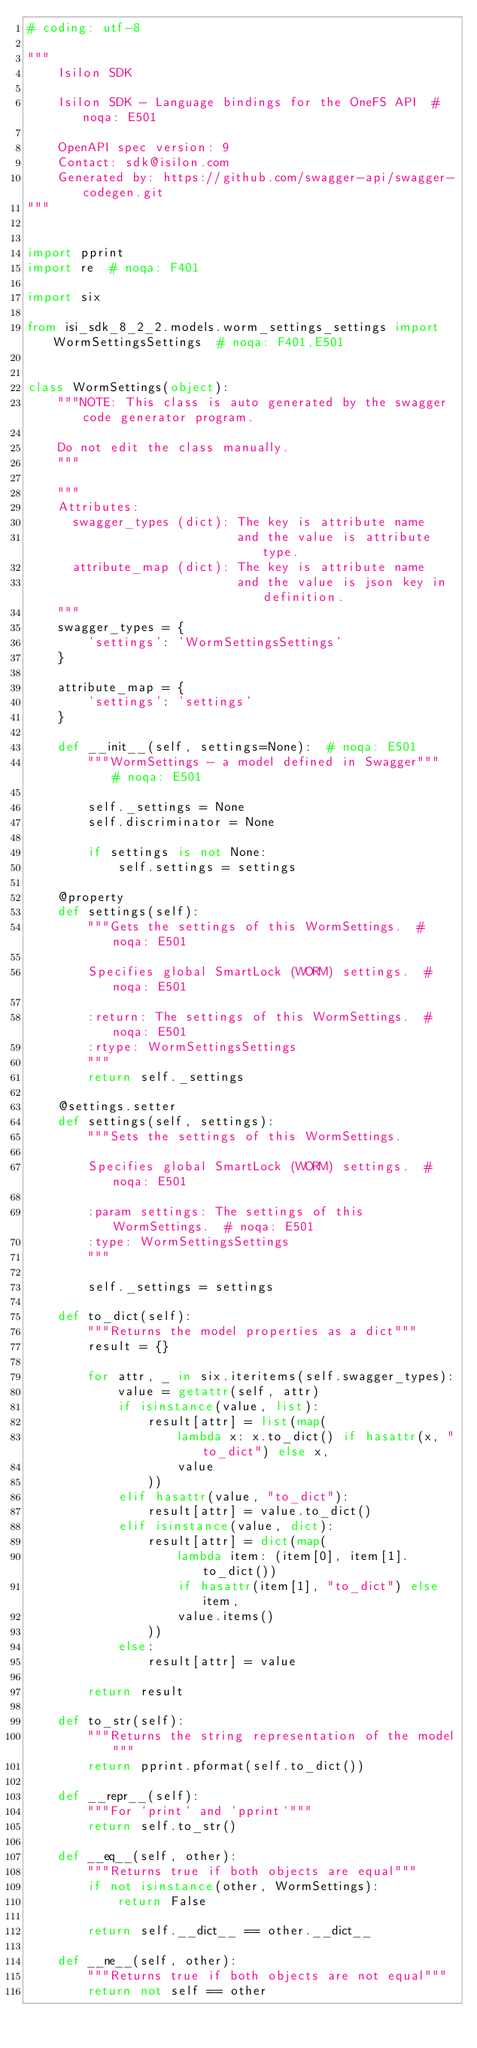<code> <loc_0><loc_0><loc_500><loc_500><_Python_># coding: utf-8

"""
    Isilon SDK

    Isilon SDK - Language bindings for the OneFS API  # noqa: E501

    OpenAPI spec version: 9
    Contact: sdk@isilon.com
    Generated by: https://github.com/swagger-api/swagger-codegen.git
"""


import pprint
import re  # noqa: F401

import six

from isi_sdk_8_2_2.models.worm_settings_settings import WormSettingsSettings  # noqa: F401,E501


class WormSettings(object):
    """NOTE: This class is auto generated by the swagger code generator program.

    Do not edit the class manually.
    """

    """
    Attributes:
      swagger_types (dict): The key is attribute name
                            and the value is attribute type.
      attribute_map (dict): The key is attribute name
                            and the value is json key in definition.
    """
    swagger_types = {
        'settings': 'WormSettingsSettings'
    }

    attribute_map = {
        'settings': 'settings'
    }

    def __init__(self, settings=None):  # noqa: E501
        """WormSettings - a model defined in Swagger"""  # noqa: E501

        self._settings = None
        self.discriminator = None

        if settings is not None:
            self.settings = settings

    @property
    def settings(self):
        """Gets the settings of this WormSettings.  # noqa: E501

        Specifies global SmartLock (WORM) settings.  # noqa: E501

        :return: The settings of this WormSettings.  # noqa: E501
        :rtype: WormSettingsSettings
        """
        return self._settings

    @settings.setter
    def settings(self, settings):
        """Sets the settings of this WormSettings.

        Specifies global SmartLock (WORM) settings.  # noqa: E501

        :param settings: The settings of this WormSettings.  # noqa: E501
        :type: WormSettingsSettings
        """

        self._settings = settings

    def to_dict(self):
        """Returns the model properties as a dict"""
        result = {}

        for attr, _ in six.iteritems(self.swagger_types):
            value = getattr(self, attr)
            if isinstance(value, list):
                result[attr] = list(map(
                    lambda x: x.to_dict() if hasattr(x, "to_dict") else x,
                    value
                ))
            elif hasattr(value, "to_dict"):
                result[attr] = value.to_dict()
            elif isinstance(value, dict):
                result[attr] = dict(map(
                    lambda item: (item[0], item[1].to_dict())
                    if hasattr(item[1], "to_dict") else item,
                    value.items()
                ))
            else:
                result[attr] = value

        return result

    def to_str(self):
        """Returns the string representation of the model"""
        return pprint.pformat(self.to_dict())

    def __repr__(self):
        """For `print` and `pprint`"""
        return self.to_str()

    def __eq__(self, other):
        """Returns true if both objects are equal"""
        if not isinstance(other, WormSettings):
            return False

        return self.__dict__ == other.__dict__

    def __ne__(self, other):
        """Returns true if both objects are not equal"""
        return not self == other
</code> 